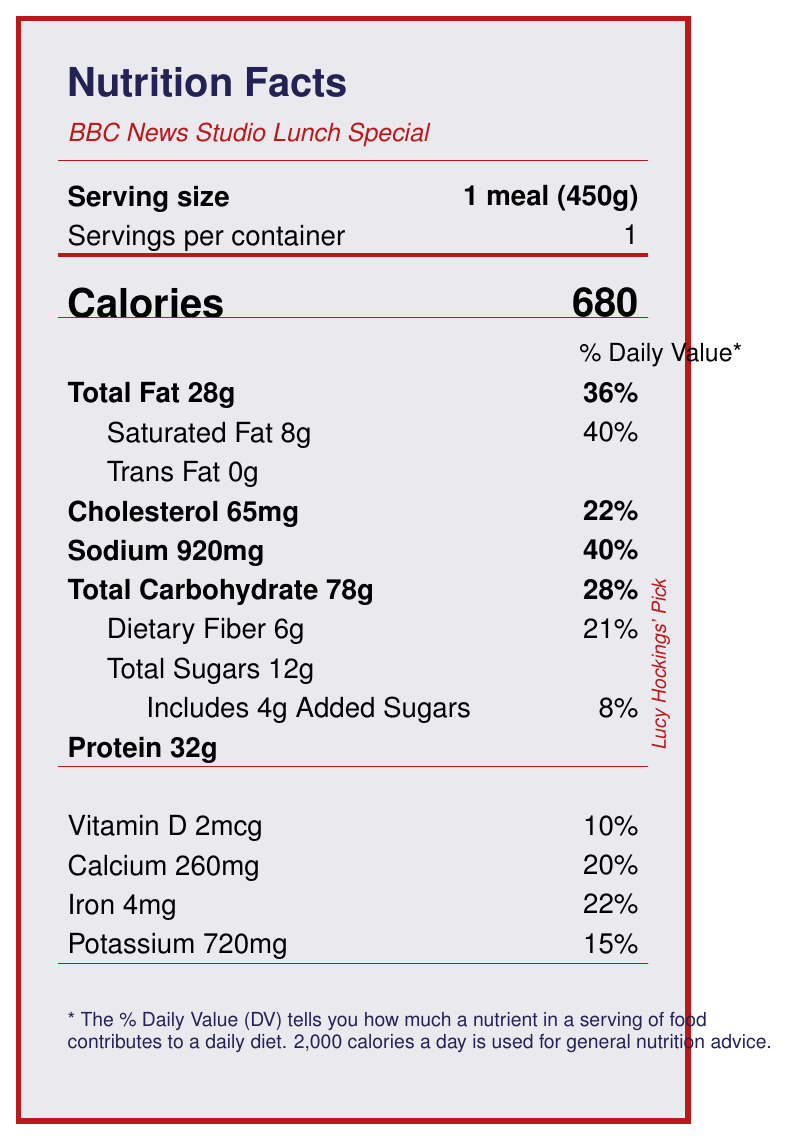what is the serving size? The document specifies the serving size as 1 meal (450g) under the Serving size section.
Answer: 1 meal (450g) how many calories are there in one serving? The document states that there are 680 calories per serving.
Answer: 680 how much saturated fat is in the meal? The document lists 8g of saturated fat in one serving.
Answer: 8g what is the total carbohydrate content per serving? The total carbohydrate content per serving is indicated as 78g in the document.
Answer: 78g how much protein does the meal contain? The document states that the meal contains 32g of protein.
Answer: 32g what percentage of the daily value does the sodium content make up? The sodium content is 920mg, which makes up 40% of the daily value.
Answer: 40% which one of these items is NOT included in the BBC News Studio Lunch Special? A. Grilled Chicken Sandwich B. BBC News Garden Salad C. Fish and Chips The document lists Lucy's Favorite Grilled Chicken Sandwich, BBC News Garden Salad, Broadcasting House Vegetable Soup, and Hockings' Hydration Juice, but does not mention Fish and Chips.
Answer: C what allergens are present in this meal? A. Wheat B. Milk C. Soy D. All of the above The document lists Wheat, Milk, and Soy as allergens, so the correct answer is D, All of the above.
Answer: D does the meal contain any trans fat? The document specifies that the trans fat content is 0g.
Answer: No summarize the main idea of the document The document details the nutritional values and ingredients of the BBC News Studio Lunch Special. It includes information on serving size, calorie content, macronutrients, micronutrients, potential allergens, and specific menu items.
Answer: The document provides detailed nutritional information for the BBC News Studio Lunch Special, including serving size, calories, macronutrients, micronutrients, allergens, and a description of the menu items. what are the ingredients of Lucy's Favorite Grilled Chicken Sandwich? The document does not provide the specific ingredients used in Lucy's Favorite Grilled Chicken Sandwich apart from the general description.
Answer: I don't know how much of the daily value of Vitamin D does the meal provide? The document states that the meal provides 2mcg of Vitamin D, which is 10% of the daily value.
Answer: 10% is it true that the packaging of this meal is made from 100% recyclable materials? The document includes a sustainability note stating that the packaging is made from 100% recyclable materials.
Answer: Yes what is the source of the ingredients used in the meal? The document mentions that the ingredients are sourced from local British farms and suppliers.
Answer: Ingredients are sourced from local British farms and suppliers 